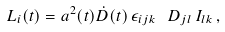<formula> <loc_0><loc_0><loc_500><loc_500>L _ { i } ( t ) = a ^ { 2 } ( t ) \dot { D } ( t ) \, \epsilon _ { i j k } \, \ D _ { j l } \, I _ { l k } \, ,</formula> 